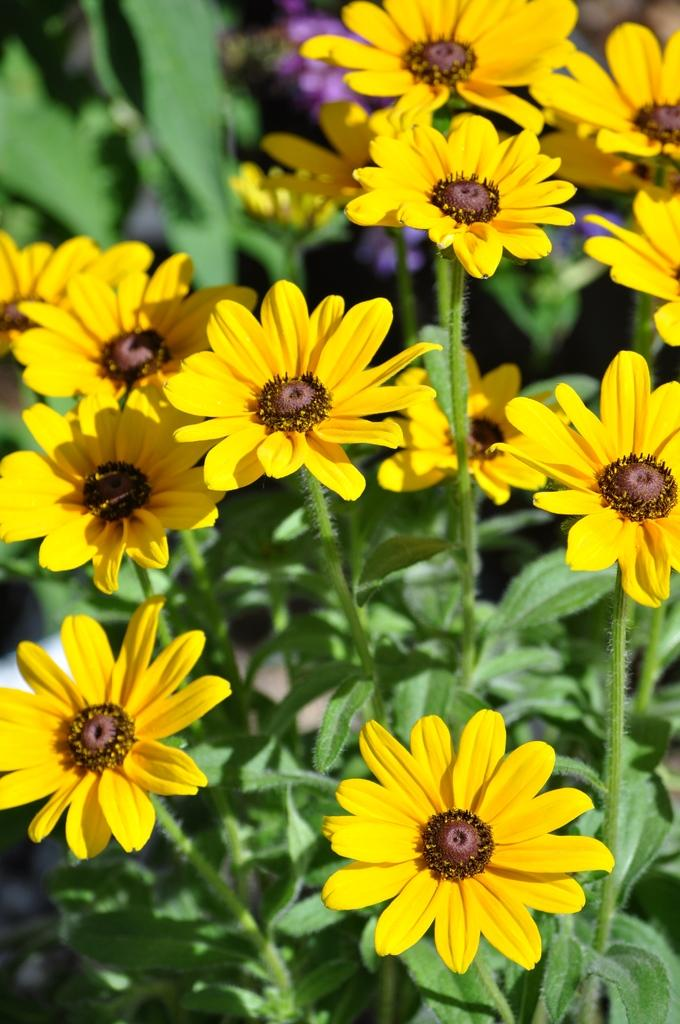What types of plants are visible in the image? There are plants with flowers in the image. Can you describe the background of the image? The background of the image is blurred. Despite the blur, what can still be seen in the background? Despite the blur, plants and flowers are visible in the background. What type of club is being used to hit the flowers in the image? There is no club present in the image, and the flowers are not being hit. 